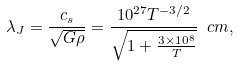Convert formula to latex. <formula><loc_0><loc_0><loc_500><loc_500>\lambda _ { J } = \frac { c _ { s } } { \sqrt { G \rho } } = \frac { 1 0 ^ { 2 7 } T ^ { - 3 / 2 } } { \sqrt { 1 + \frac { 3 \times 1 0 ^ { 8 } } { T } } } \ c m ,</formula> 